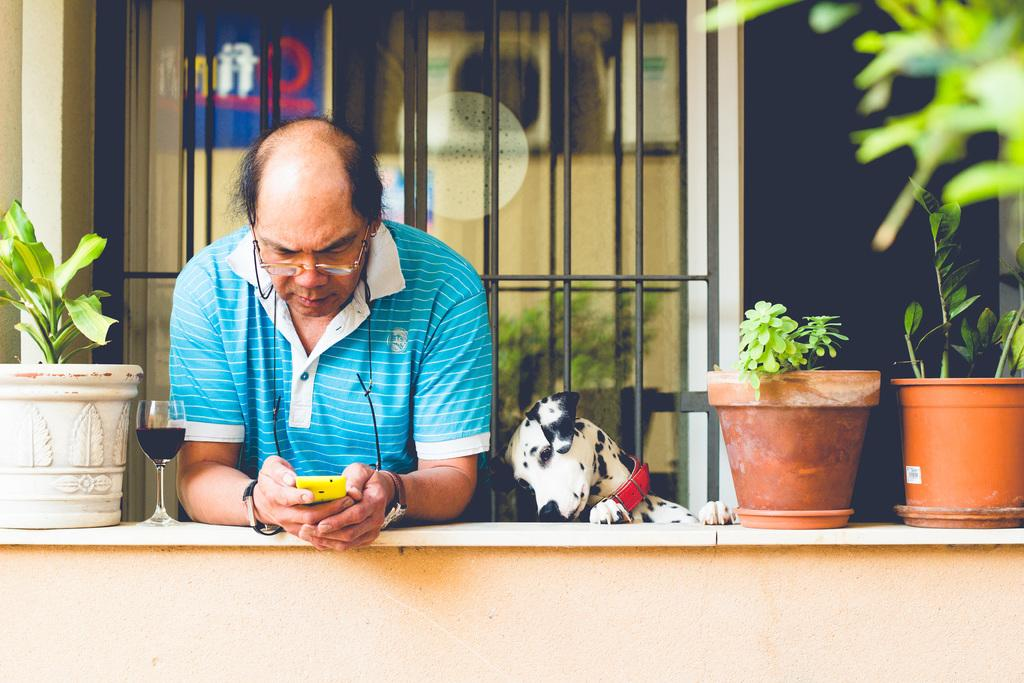Who is present in the image? There is a man in the image. What is the man wearing? The man is wearing a blue t-shirt. What is the man holding in the image? The man is holding a phone. Can you describe any other objects or features in the image? There is a plant pot on the wall and a window in the background of the image. Additionally, there is a dog standing beside the man. How much money is in the man's pocket in the image? There is no information about money or pockets in the image, so we cannot determine the amount of money in the man's pocket. Is there a kite visible in the image? No, there is no kite present in the image. 